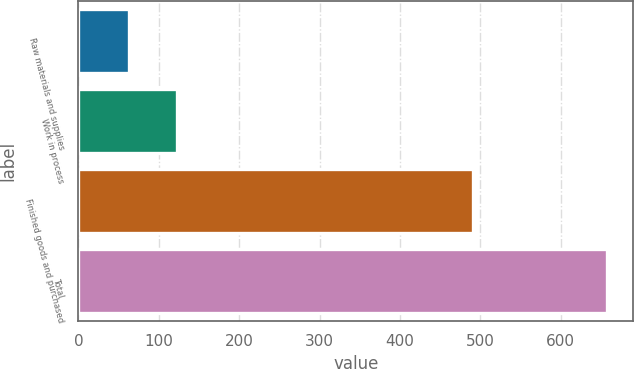Convert chart to OTSL. <chart><loc_0><loc_0><loc_500><loc_500><bar_chart><fcel>Raw materials and supplies<fcel>Work in process<fcel>Finished goods and purchased<fcel>Total<nl><fcel>62.6<fcel>122.09<fcel>490.7<fcel>657.5<nl></chart> 